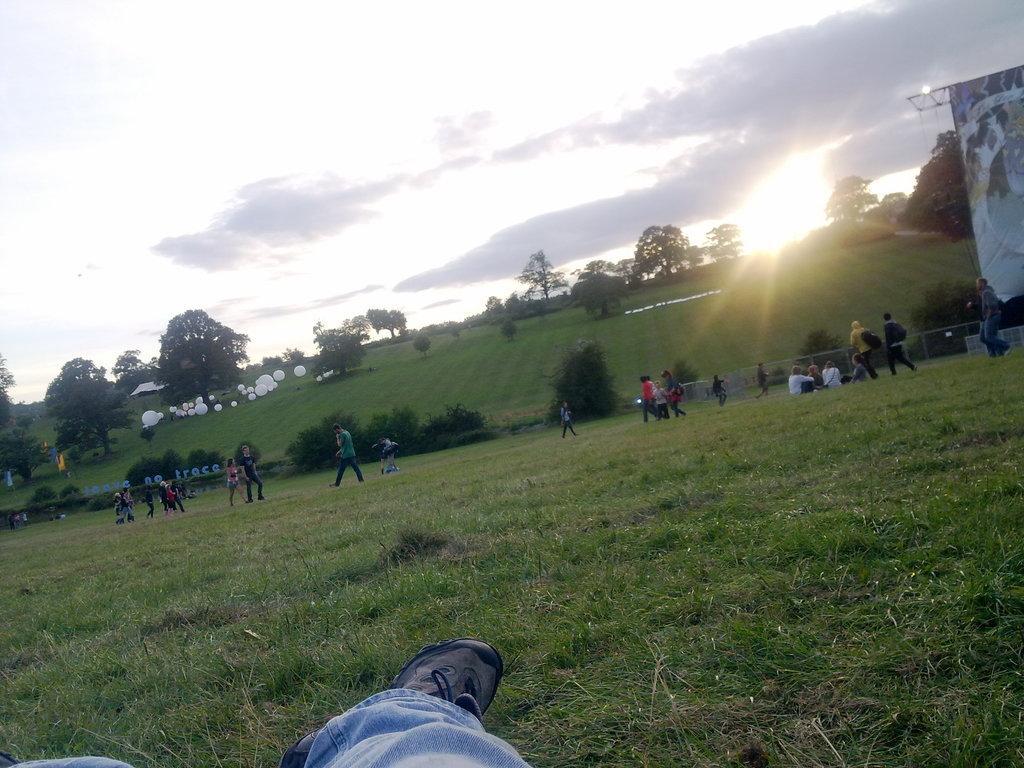Describe this image in one or two sentences. In this image there is a person , and at the background there are group of persons standing on the grass, banner, boards, balloons, trees,sky. 